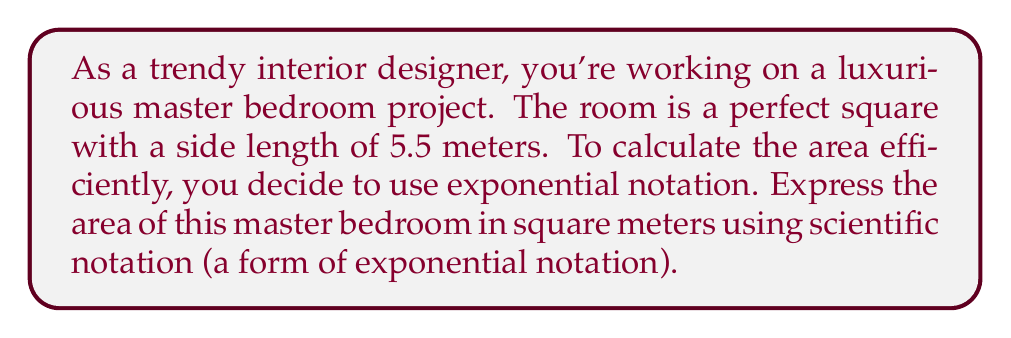Provide a solution to this math problem. To solve this problem, let's follow these steps:

1) The formula for the area of a square is:
   $$A = s^2$$
   where $A$ is the area and $s$ is the side length.

2) We're given that the side length is 5.5 meters. Let's substitute this into our formula:
   $$A = (5.5)^2$$

3) Now, let's calculate this:
   $$(5.5)^2 = 5.5 \times 5.5 = 30.25$$

4) To express this in scientific notation, we need to write it in the form $a \times 10^n$, where $1 \leq |a| < 10$ and $n$ is an integer.

5) In this case:
   $$30.25 = 3.025 \times 10^1$$

Therefore, the area of the master bedroom in scientific notation is $3.025 \times 10^1$ square meters.
Answer: $3.025 \times 10^1$ m² 